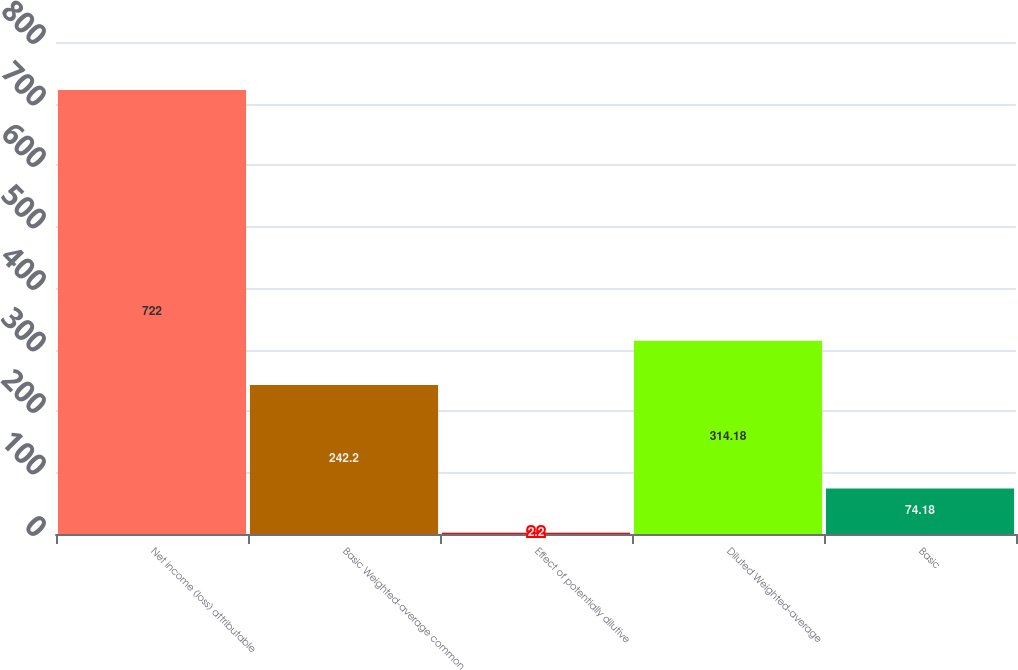Convert chart. <chart><loc_0><loc_0><loc_500><loc_500><bar_chart><fcel>Net income (loss) attributable<fcel>Basic Weighted-average common<fcel>Effect of potentially dilutive<fcel>Diluted Weighted-average<fcel>Basic<nl><fcel>722<fcel>242.2<fcel>2.2<fcel>314.18<fcel>74.18<nl></chart> 